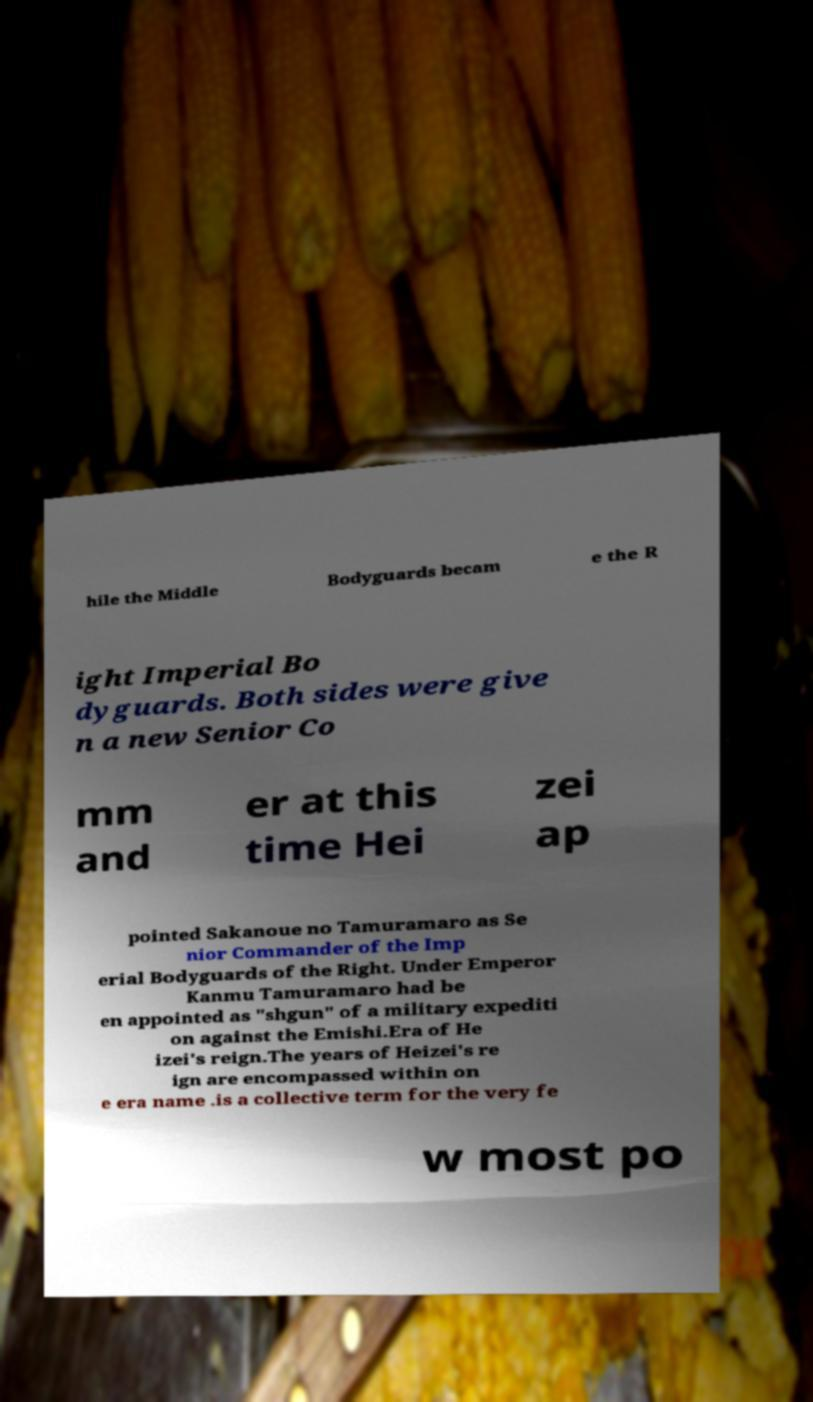Can you read and provide the text displayed in the image?This photo seems to have some interesting text. Can you extract and type it out for me? hile the Middle Bodyguards becam e the R ight Imperial Bo dyguards. Both sides were give n a new Senior Co mm and er at this time Hei zei ap pointed Sakanoue no Tamuramaro as Se nior Commander of the Imp erial Bodyguards of the Right. Under Emperor Kanmu Tamuramaro had be en appointed as "shgun" of a military expediti on against the Emishi.Era of He izei's reign.The years of Heizei's re ign are encompassed within on e era name .is a collective term for the very fe w most po 